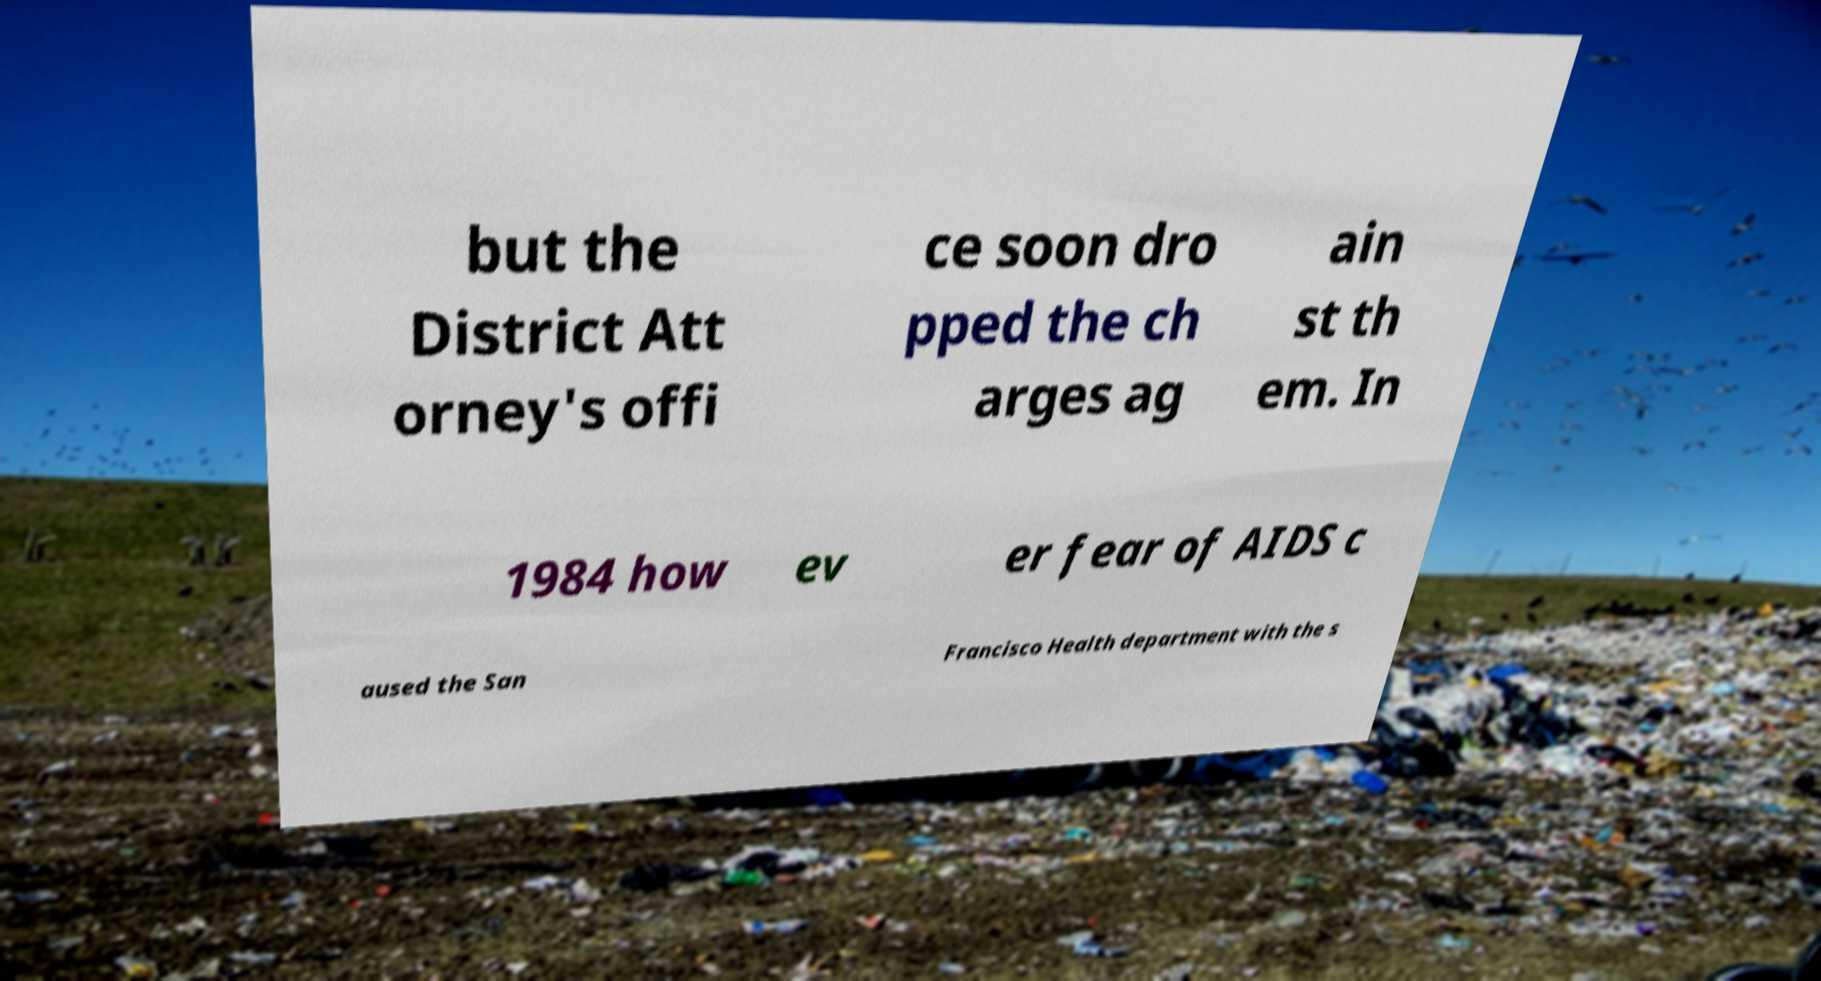For documentation purposes, I need the text within this image transcribed. Could you provide that? but the District Att orney's offi ce soon dro pped the ch arges ag ain st th em. In 1984 how ev er fear of AIDS c aused the San Francisco Health department with the s 